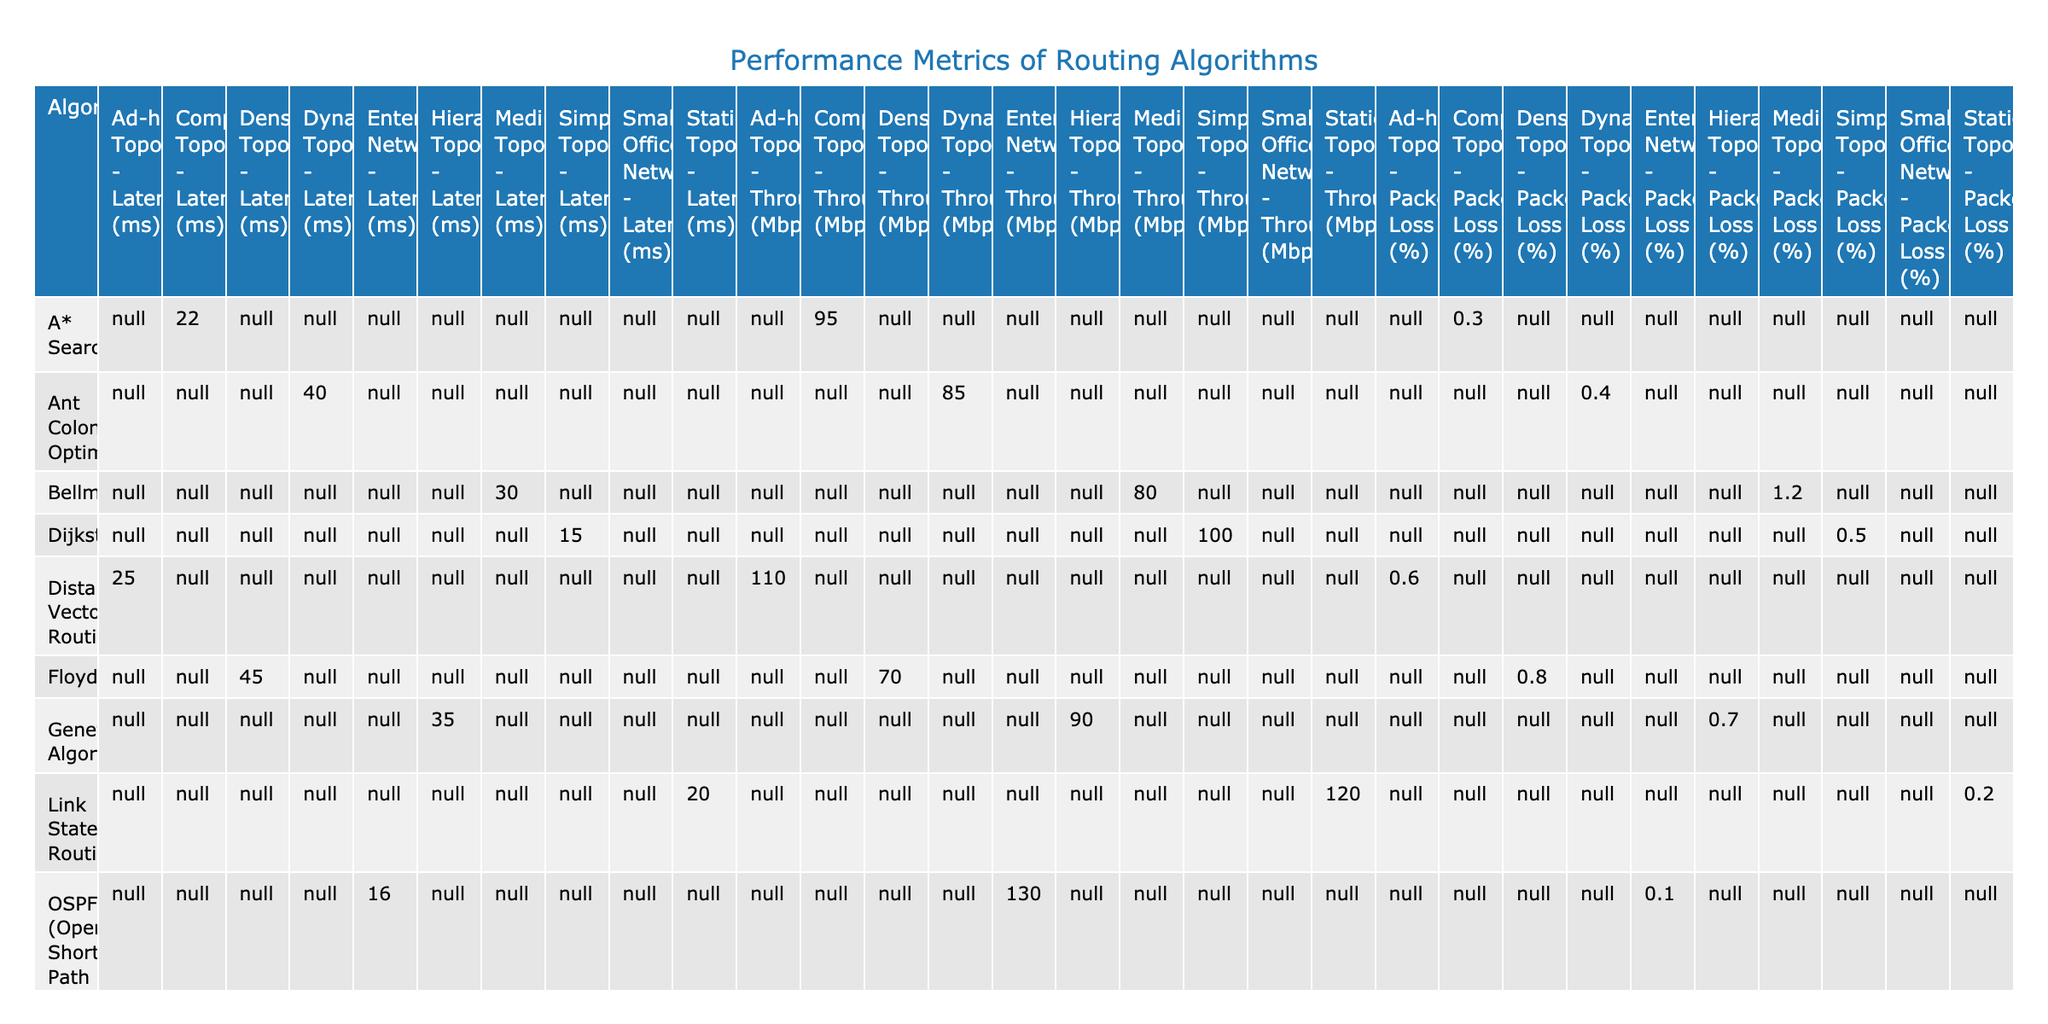What is the latency of the OSPF algorithm? The table shows that the OSPF algorithm has a latency of 16 ms under the Enterprise Network configuration.
Answer: 16 ms Which algorithm has the highest packet loss percentage? In the table, the Bellman-Ford algorithm has the highest packet loss percentage listed at 1.2%.
Answer: 1.2% What is the average throughput of all algorithms listed? The total throughput is calculated by adding all the throughputs: (100 + 95 + 80 + 70 + 85 + 90 + 120 + 110 + 130 + 75) = 1,055. There are 10 algorithms in total, so the average throughput is 1,055 / 10 = 105.5 Mbps.
Answer: 105.5 Mbps Does the Genetic Algorithm have a lower latency than Distance Vector Routing? The latency for the Genetic Algorithm is 35 ms, while the latency for Distance Vector Routing is 25 ms. Since 35 ms is greater than 25 ms, the statement is false.
Answer: No What is the difference in latency between the Ant Colony Optimization and the Dijkstra algorithms? The latency for Ant Colony Optimization is 40 ms and for Dijkstra is 15 ms. The difference is 40 ms - 15 ms = 25 ms.
Answer: 25 ms Which routing algorithm under the Static Topology has the best throughput? The Link State Routing algorithm shows the highest throughput of 120 Mbps under the Static Topology, compared to 0 for other algorithms in that category.
Answer: 120 Mbps Is the packet loss percentage for the A* Search algorithm lower than that of the Floyd-Warshall algorithm? The packet loss for A* Search is 0.3%, while that for Floyd-Warshall is 0.8%. Since 0.3% is less than 0.8%, the statement is true.
Answer: Yes What is the overall trend for latency across different routing algorithms? Looking at the latencies for all algorithms, there seems to be an increasing trend from the lowest (Dijkstra) at 15 ms to the highest (Floyd-Warshall) at 45 ms, showing that more complex algorithms generally have higher latencies.
Answer: Increasing trend Which algorithm offered a latency improvement over the average latency of all algorithms? The average latency is (15 + 22 + 30 + 45 + 40 + 35 + 20 + 25 + 16 + 28) = 28.1 ms. The Dijkstra algorithm has a latency of 15 ms, which is below the average, showing improvement.
Answer: Yes 